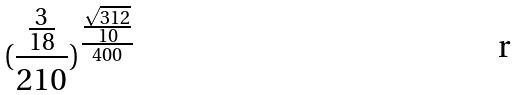Convert formula to latex. <formula><loc_0><loc_0><loc_500><loc_500>( \frac { \frac { 3 } { 1 8 } } { 2 1 0 } ) ^ { \frac { \frac { \sqrt { 3 1 2 } } { 1 0 } } { 4 0 0 } }</formula> 